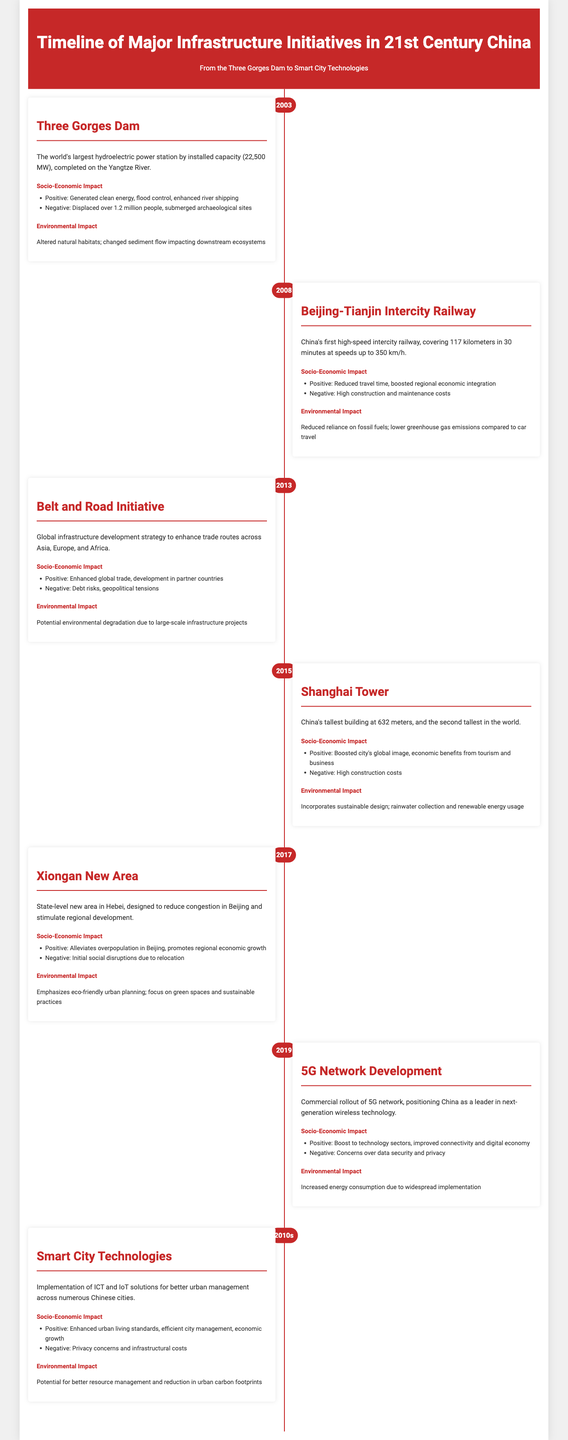What year was the Three Gorges Dam completed? The document states that the Three Gorges Dam was completed in 2003.
Answer: 2003 What is the installed capacity of the Three Gorges Dam? The document mentions that the Three Gorges Dam has an installed capacity of 22,500 MW.
Answer: 22,500 MW What type of transportation does the Beijing-Tianjin Intercity Railway offer? It is noted in the document that the Beijing-Tianjin Intercity Railway is China's first high-speed intercity railway.
Answer: High-speed intercity railway What year did the 5G Network Development start? The document indicates that the commercial rollout of the 5G network began in 2019.
Answer: 2019 What was a negative socio-economic impact of the Xiongan New Area? According to the document, a negative impact was initial social disruptions due to relocation.
Answer: Social disruptions What initiative does the 5G Network Development position China as a leader in? The document states that the 5G Network Development positions China as a leader in next-generation wireless technology.
Answer: Next-generation wireless technology How tall is the Shanghai Tower? The document describes the Shanghai Tower as being 632 meters tall.
Answer: 632 meters What does the Smart City Technologies implementation aim to enhance? The document explains that the aim of Smart City Technologies is to enhance urban living standards.
Answer: Urban living standards What are the potential environmental benefits of Smart City Technologies? The document mentions that Smart City Technologies have the potential for better resource management and reduction in urban carbon footprints.
Answer: Better resource management and reduction in urban carbon footprints 